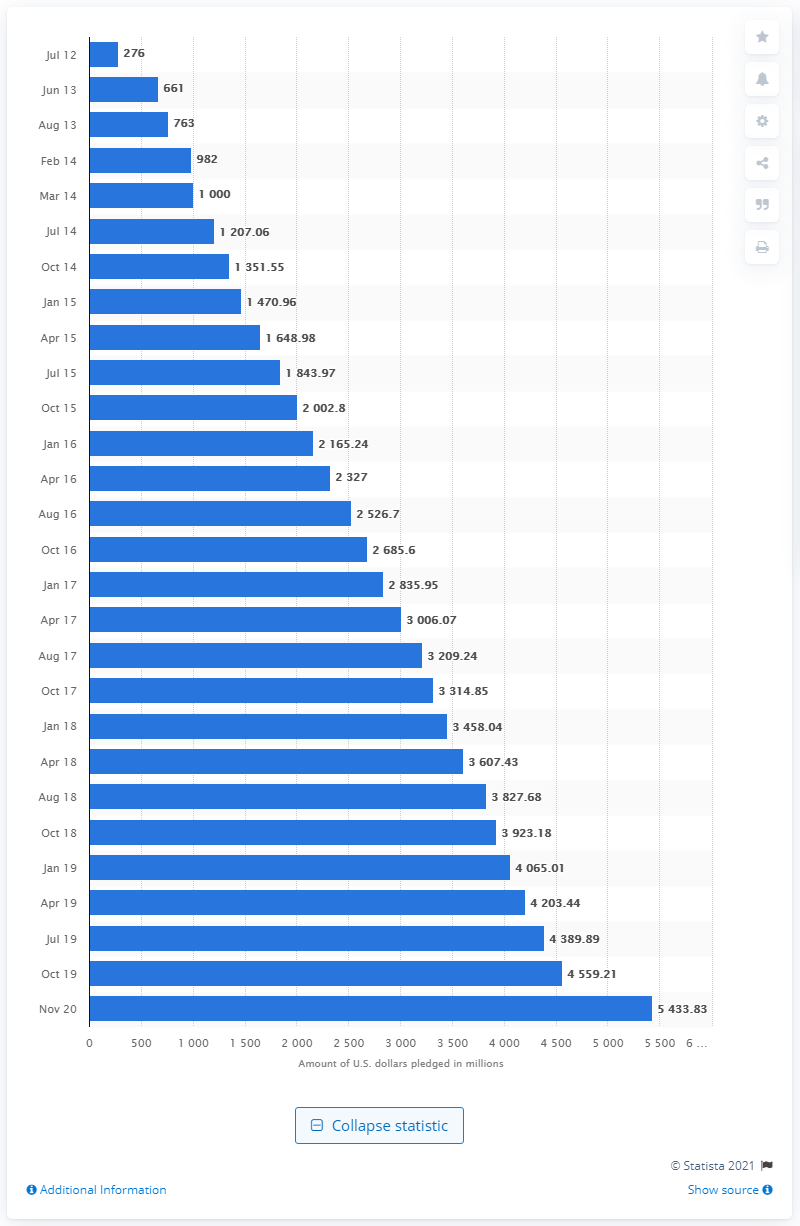List a handful of essential elements in this visual. As of November 2020, a total of 5,433.83 dollars had been pledged to projects on the crowdfunding platform from July 2012 to November 2020. 